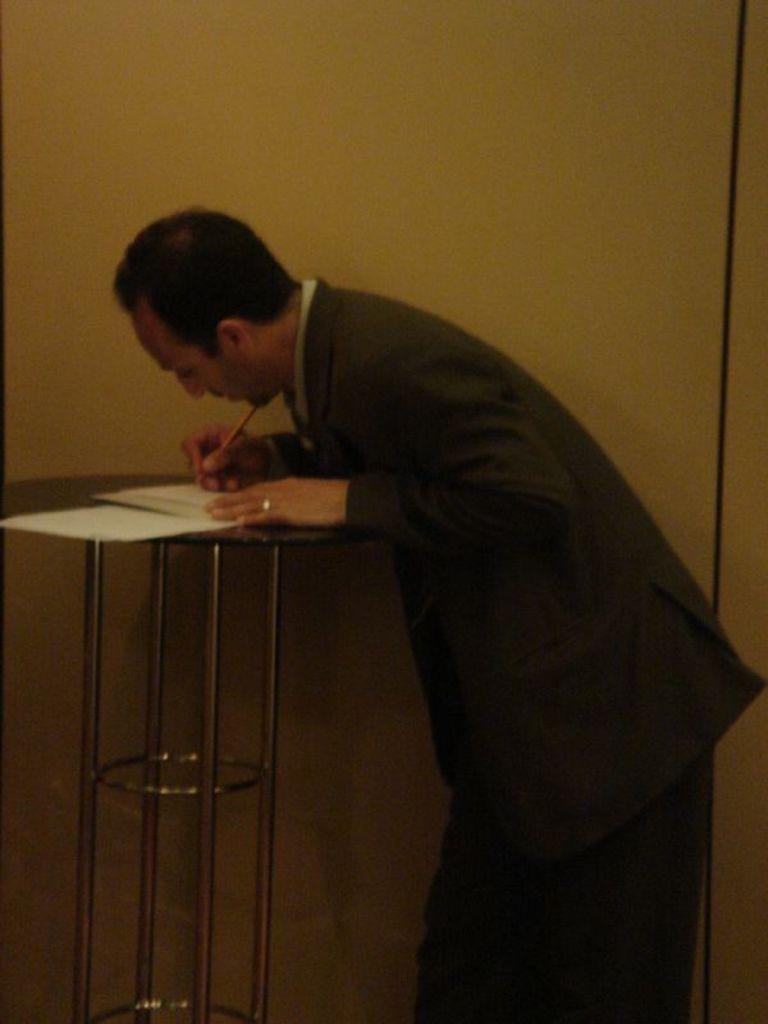Describe this image in one or two sentences. This man is holding a pen. On this table there are papers. 